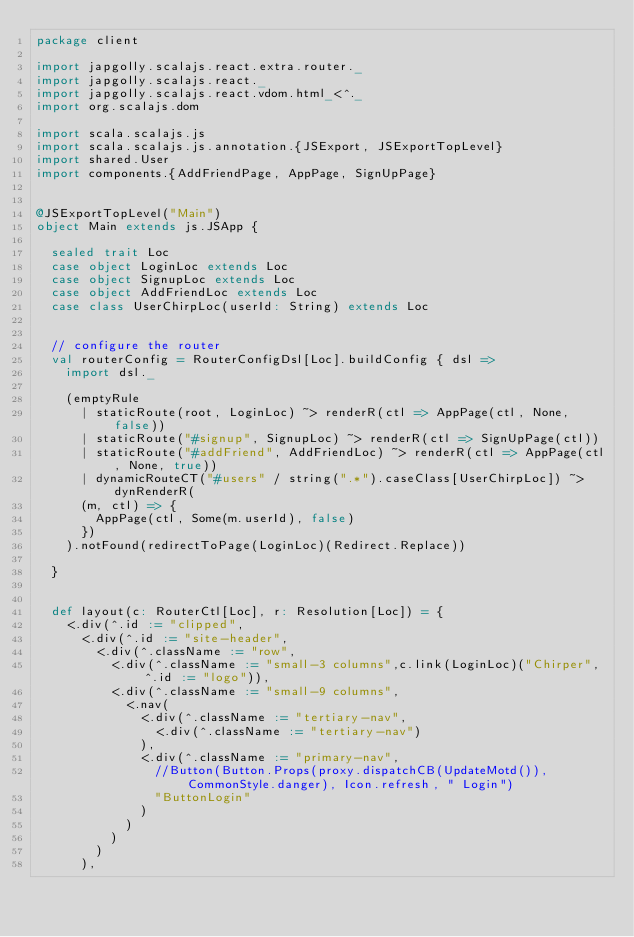Convert code to text. <code><loc_0><loc_0><loc_500><loc_500><_Scala_>package client

import japgolly.scalajs.react.extra.router._
import japgolly.scalajs.react._
import japgolly.scalajs.react.vdom.html_<^._
import org.scalajs.dom

import scala.scalajs.js
import scala.scalajs.js.annotation.{JSExport, JSExportTopLevel}
import shared.User
import components.{AddFriendPage, AppPage, SignUpPage}


@JSExportTopLevel("Main")
object Main extends js.JSApp {

  sealed trait Loc
  case object LoginLoc extends Loc
  case object SignupLoc extends Loc
  case object AddFriendLoc extends Loc
  case class UserChirpLoc(userId: String) extends Loc


  // configure the router
  val routerConfig = RouterConfigDsl[Loc].buildConfig { dsl =>
    import dsl._

    (emptyRule
      | staticRoute(root, LoginLoc) ~> renderR(ctl => AppPage(ctl, None, false))
      | staticRoute("#signup", SignupLoc) ~> renderR(ctl => SignUpPage(ctl))
      | staticRoute("#addFriend", AddFriendLoc) ~> renderR(ctl => AppPage(ctl, None, true))
      | dynamicRouteCT("#users" / string(".*").caseClass[UserChirpLoc]) ~> dynRenderR(
      (m, ctl) => {
        AppPage(ctl, Some(m.userId), false)
      })
    ).notFound(redirectToPage(LoginLoc)(Redirect.Replace))

  }


  def layout(c: RouterCtl[Loc], r: Resolution[Loc]) = {
    <.div(^.id := "clipped",
      <.div(^.id := "site-header",
        <.div(^.className := "row",
          <.div(^.className := "small-3 columns",c.link(LoginLoc)("Chirper", ^.id := "logo")),
          <.div(^.className := "small-9 columns",
            <.nav(
              <.div(^.className := "tertiary-nav",
                <.div(^.className := "tertiary-nav")
              ),
              <.div(^.className := "primary-nav",
                //Button(Button.Props(proxy.dispatchCB(UpdateMotd()), CommonStyle.danger), Icon.refresh, " Login")
                "ButtonLogin"
              )
            )
          )
        )
      ),</code> 